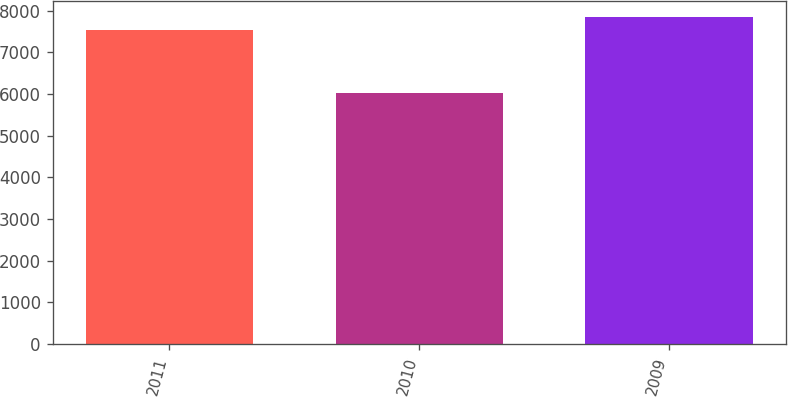Convert chart to OTSL. <chart><loc_0><loc_0><loc_500><loc_500><bar_chart><fcel>2011<fcel>2010<fcel>2009<nl><fcel>7544<fcel>6035<fcel>7841<nl></chart> 